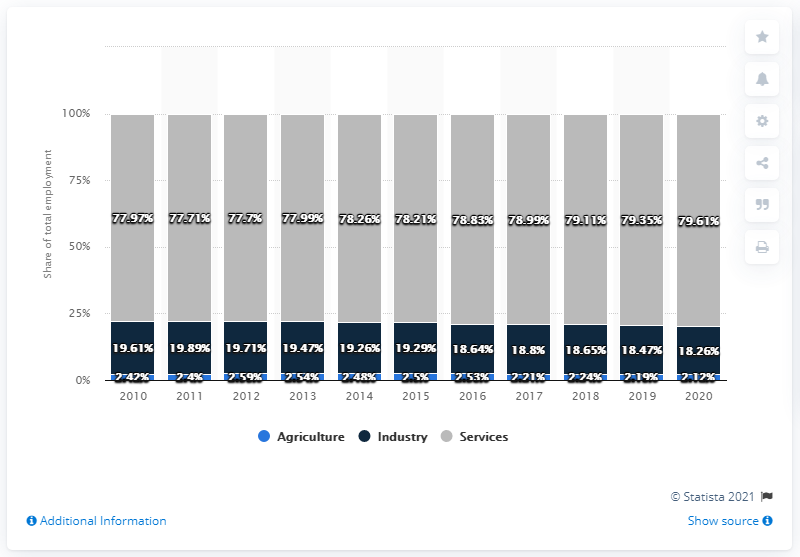List a handful of essential elements in this visual. For how many years has the services component exceeded 75%? The answer is 11 years. The difference in the percentage of Services between 2010 and 2020 is 1.64%. 